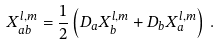Convert formula to latex. <formula><loc_0><loc_0><loc_500><loc_500>X ^ { l , m } _ { a b } = \frac { 1 } { 2 } \left ( D _ { a } X _ { b } ^ { l , m } + D _ { b } X _ { a } ^ { l , m } \right ) \, .</formula> 